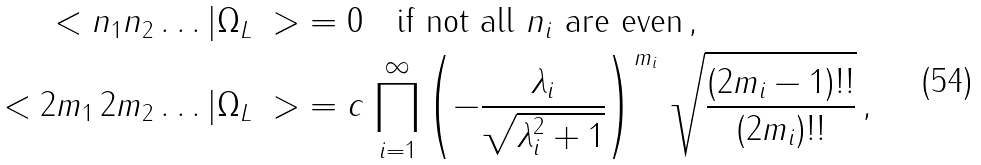Convert formula to latex. <formula><loc_0><loc_0><loc_500><loc_500>\ < n _ { 1 } n _ { 2 } \dots | \Omega _ { L } \ > & = 0 \quad \text {if not all $n_{i}$ are even} \, , \\ \ < 2 m _ { 1 } \, 2 m _ { 2 } \dots | \Omega _ { L } \ > & = c \, \prod _ { i = 1 } ^ { \infty } \left ( - \frac { \lambda _ { i } } { \sqrt { \lambda _ { i } ^ { 2 } + 1 } } \right ) ^ { m _ { i } } \, \sqrt { \frac { ( 2 m _ { i } - 1 ) ! ! } { ( 2 m _ { i } ) ! ! } } \, ,</formula> 